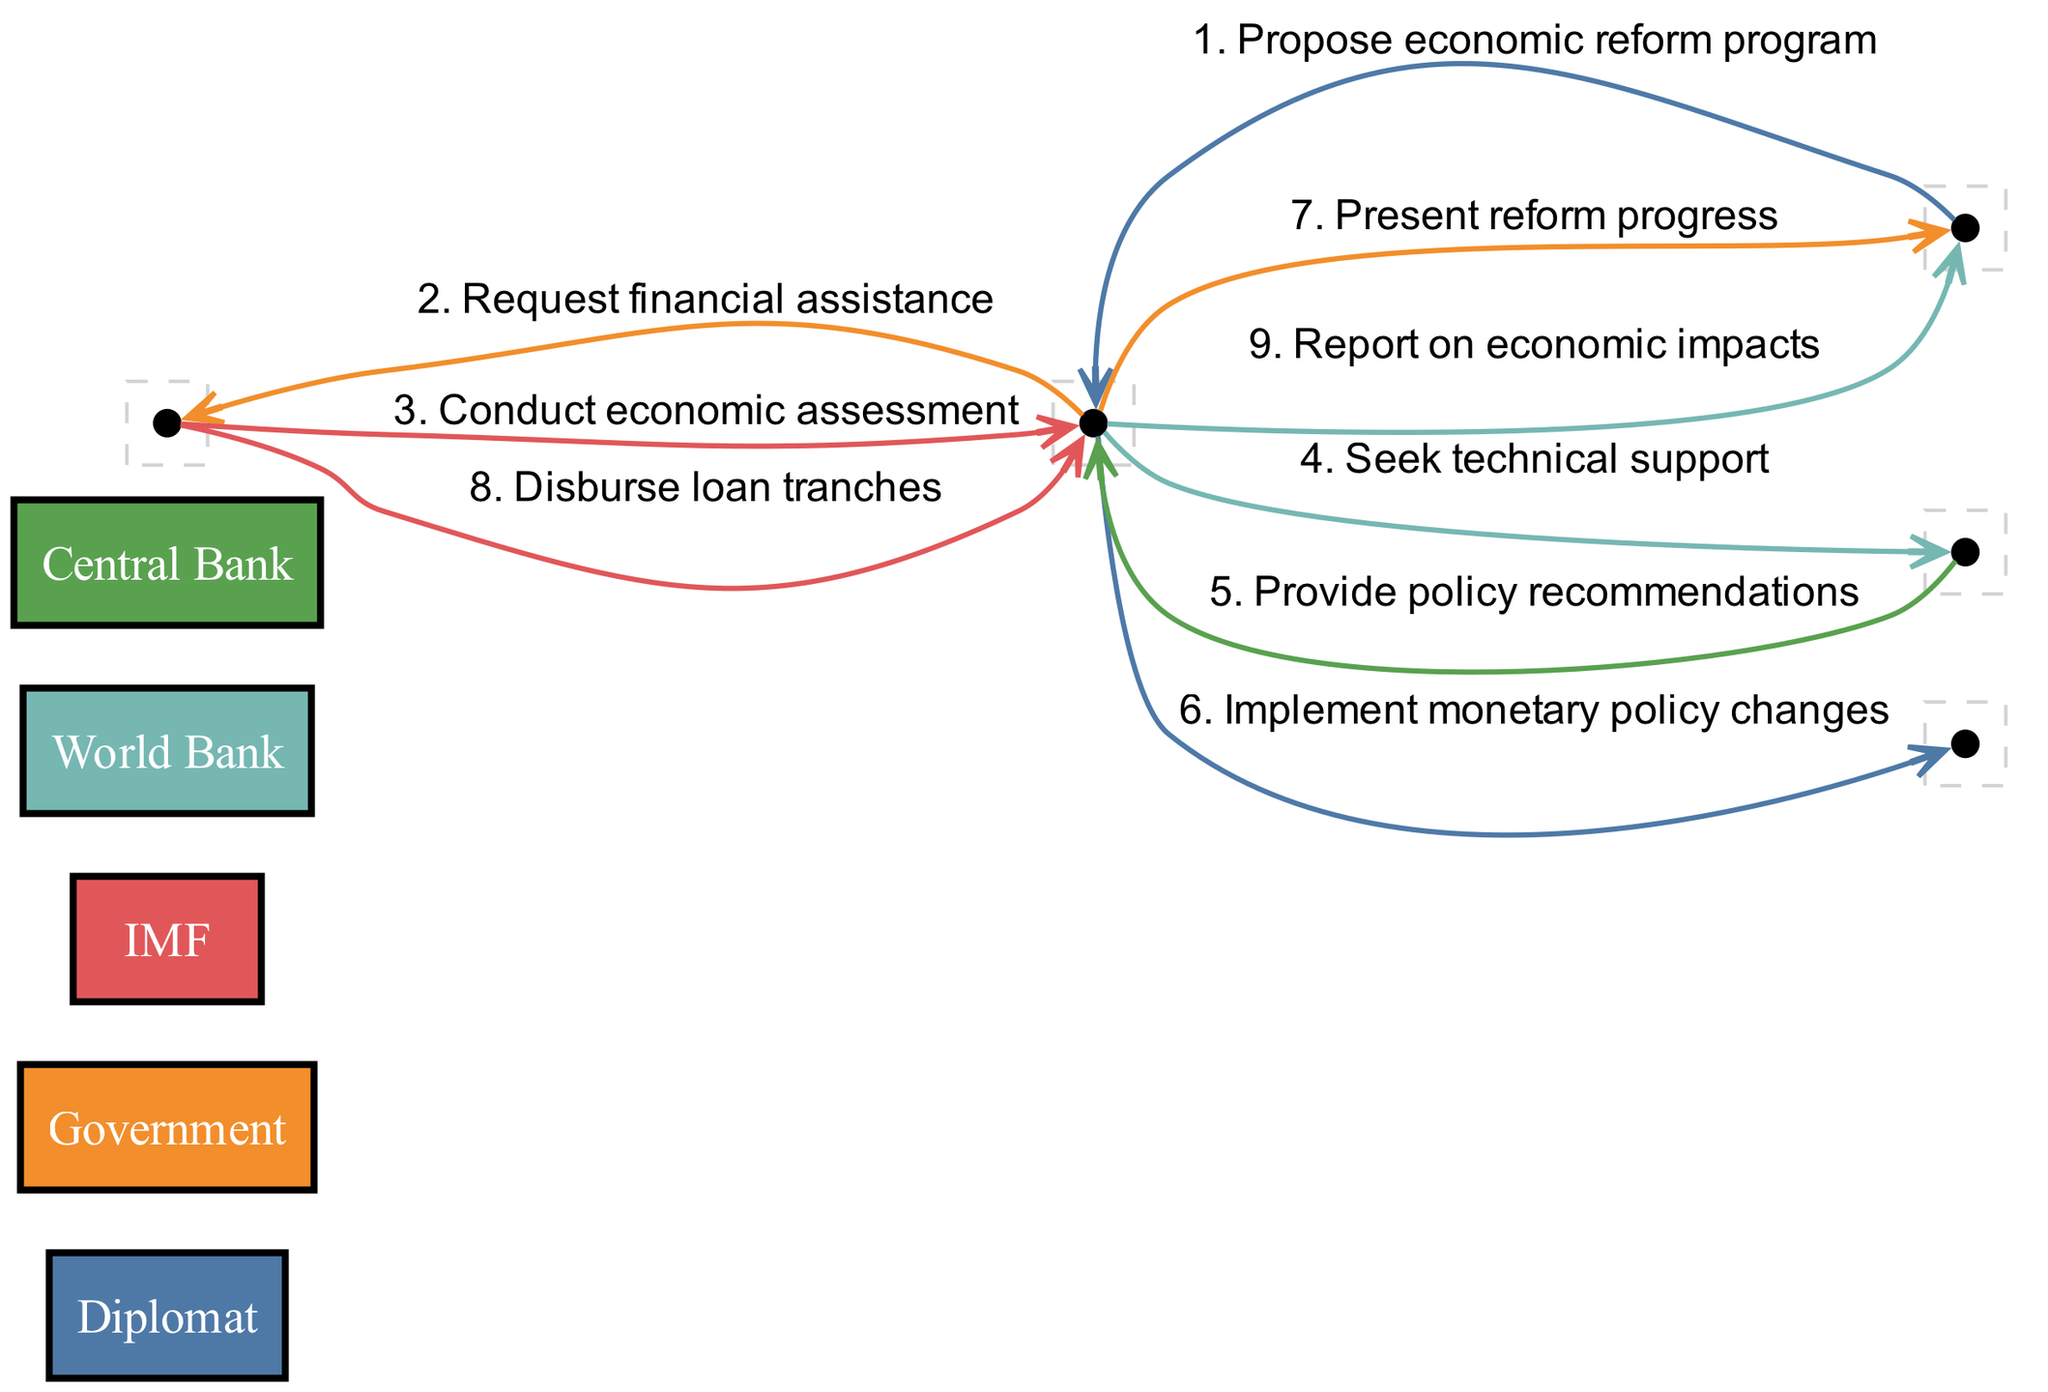What's the total number of actors in the diagram? The diagram lists five distinct actors: Diplomat, Government, IMF, World Bank, and Central Bank. Counting these gives a total of five actors.
Answer: 5 What message does the Government send to the IMF? The Government requests financial assistance from the IMF, which is explicitly stated in the message line between these two actors in the diagram.
Answer: Request financial assistance Which two actors are involved in providing policy recommendations? The World Bank is the only actor that provides policy recommendations to the Government, as shown in the directed edge between them in the sequence diagram.
Answer: World Bank and Government How many messages are sent from the Government in the diagram? By reviewing the sequence of messages, it is noted that the Government sends a total of four messages: requesting financial assistance, seeking technical support, implementing monetary policy changes, and reporting on economic impacts.
Answer: 4 What relationship do the IMF and Government share in the context of loan disbursement? The IMF and Government are connected through a message that indicates the IMF disburses loan tranches to the Government, reflecting a financial relationship focused on economic reform support.
Answer: Disburse loan tranches What is the sequence of assistance from the World Bank to the Government? The sequence tied to the World Bank shows it first provides policy recommendations, which follows a request from the Government seeking technical support. This indicates a supportive role where the World Bank assesses and advises on policies after an official request.
Answer: Provide policy recommendations Which actors are involved in the communication of reform progress? The interaction regarding reform progress involves the Government and the Diplomat, where the Government presents progress updates to the Diplomat. This interaction reflects the flow of communication between domestic and diplomatic actors.
Answer: Government and Diplomat Where does the initial proposal of the economic reform program originate? The initial proposal of the economic reform program originates from the Diplomat, who communicates this to the Government as the first step in the sequence diagram, initiating the collaborative process.
Answer: Diplomat What is the final message in the sequence regarding economic impacts? The Government reports on economic impacts as the last message in the sequence, indicating a wrap-up of the reform process and its outcomes to the Diplomat, who plays the intermediary role.
Answer: Report on economic impacts 